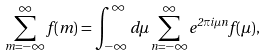Convert formula to latex. <formula><loc_0><loc_0><loc_500><loc_500>\sum _ { m = - \infty } ^ { \infty } f ( m ) = \int _ { - \infty } ^ { \infty } d \mu \sum _ { n = - \infty } ^ { \infty } e ^ { 2 \pi i \mu n } f ( \mu ) ,</formula> 